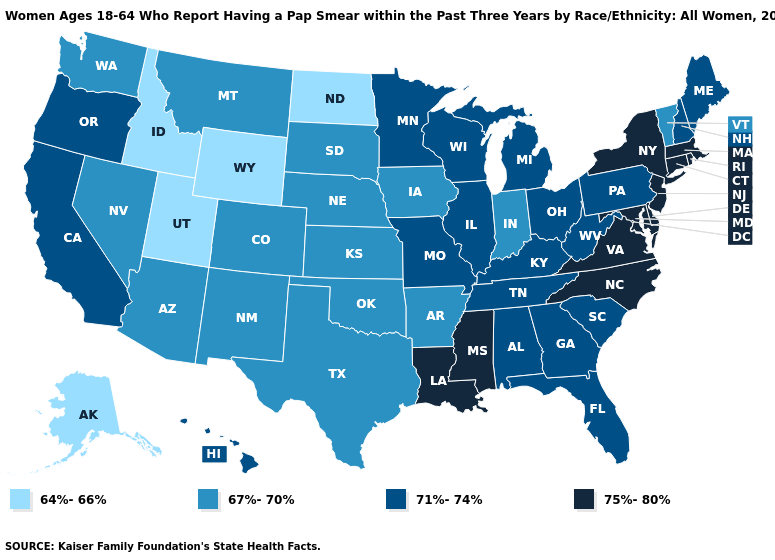Name the states that have a value in the range 64%-66%?
Concise answer only. Alaska, Idaho, North Dakota, Utah, Wyoming. Name the states that have a value in the range 75%-80%?
Short answer required. Connecticut, Delaware, Louisiana, Maryland, Massachusetts, Mississippi, New Jersey, New York, North Carolina, Rhode Island, Virginia. How many symbols are there in the legend?
Short answer required. 4. Does Maryland have the same value as Hawaii?
Keep it brief. No. Which states have the highest value in the USA?
Concise answer only. Connecticut, Delaware, Louisiana, Maryland, Massachusetts, Mississippi, New Jersey, New York, North Carolina, Rhode Island, Virginia. What is the value of Massachusetts?
Write a very short answer. 75%-80%. Does South Dakota have a higher value than New York?
Write a very short answer. No. What is the lowest value in states that border Pennsylvania?
Write a very short answer. 71%-74%. Which states have the highest value in the USA?
Give a very brief answer. Connecticut, Delaware, Louisiana, Maryland, Massachusetts, Mississippi, New Jersey, New York, North Carolina, Rhode Island, Virginia. Is the legend a continuous bar?
Concise answer only. No. What is the value of North Dakota?
Concise answer only. 64%-66%. Does Maryland have the same value as Louisiana?
Be succinct. Yes. Among the states that border Texas , does Oklahoma have the highest value?
Concise answer only. No. Which states have the lowest value in the Northeast?
Short answer required. Vermont. Which states hav the highest value in the Northeast?
Concise answer only. Connecticut, Massachusetts, New Jersey, New York, Rhode Island. 